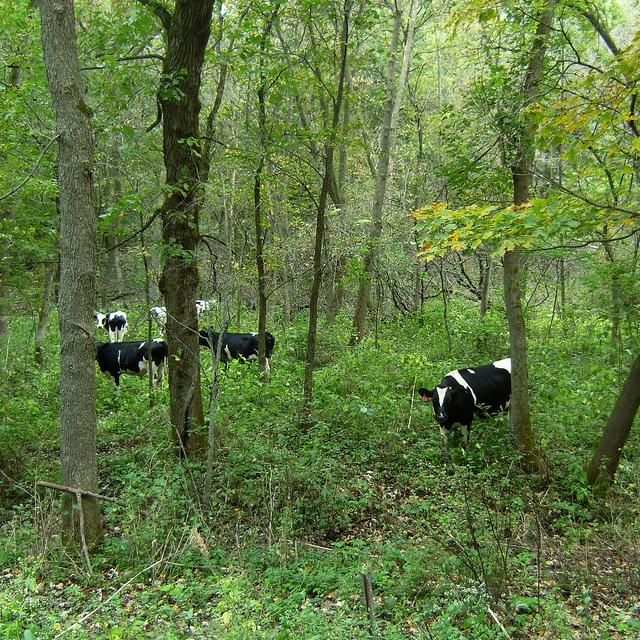Why are the cows in the woods?
Keep it brief. Grazing. Are all of the cows the same color?
Keep it brief. Yes. Are the cows supposed to be here?
Keep it brief. No. 